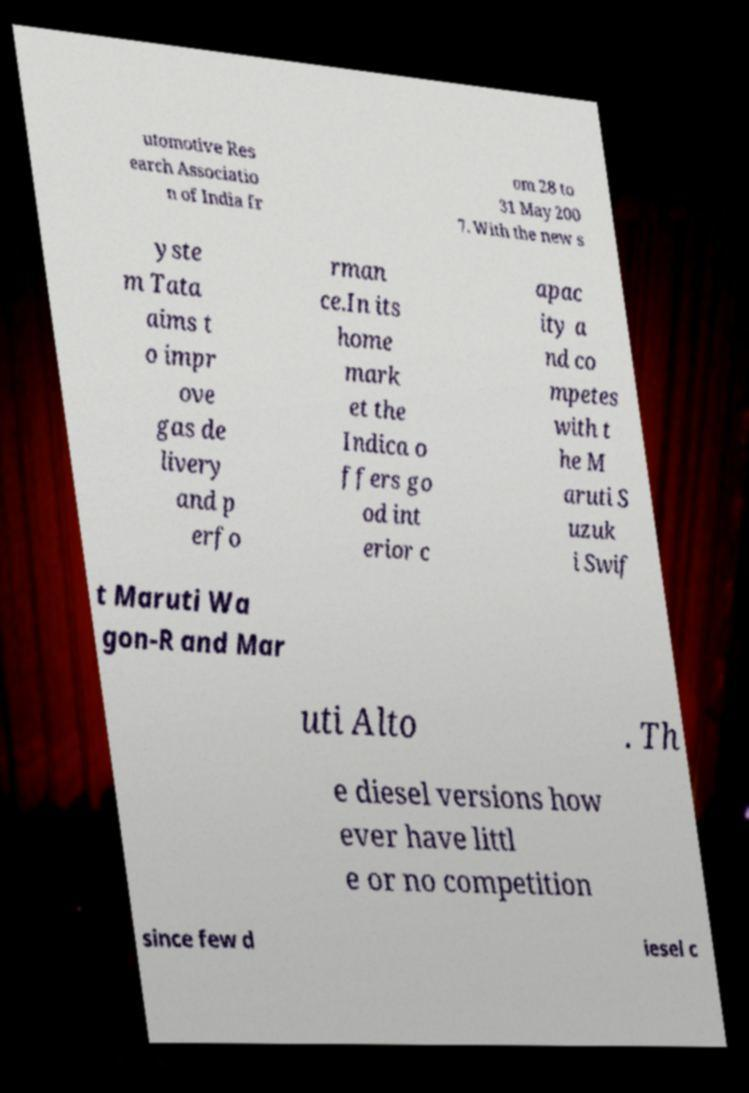Could you assist in decoding the text presented in this image and type it out clearly? utomotive Res earch Associatio n of India fr om 28 to 31 May 200 7. With the new s yste m Tata aims t o impr ove gas de livery and p erfo rman ce.In its home mark et the Indica o ffers go od int erior c apac ity a nd co mpetes with t he M aruti S uzuk i Swif t Maruti Wa gon-R and Mar uti Alto . Th e diesel versions how ever have littl e or no competition since few d iesel c 